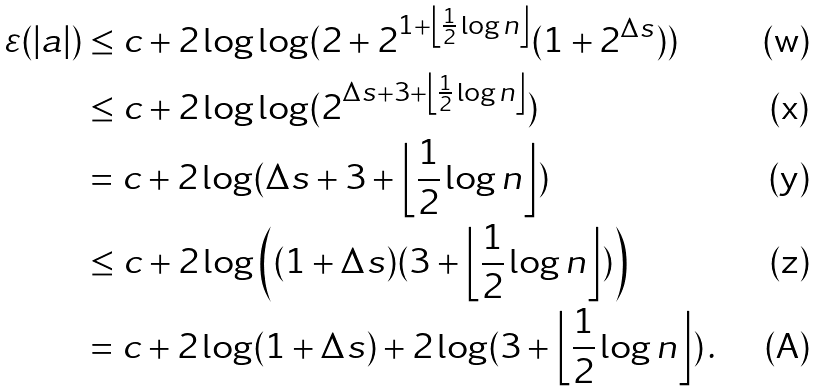Convert formula to latex. <formula><loc_0><loc_0><loc_500><loc_500>\varepsilon ( | a | ) & \leq c + 2 \log \log ( 2 + 2 ^ { 1 + \left \lfloor \frac { 1 } { 2 } \log n \right \rfloor } ( 1 + 2 ^ { \Delta s } ) ) \\ & \leq c + 2 \log \log ( 2 ^ { \Delta s + 3 + \left \lfloor \frac { 1 } { 2 } \log n \right \rfloor } ) \\ & = c + 2 \log ( \Delta s + 3 + \left \lfloor \frac { 1 } { 2 } \log n \right \rfloor ) \\ & \leq c + 2 \log \left ( ( 1 + \Delta s ) ( 3 + \left \lfloor \frac { 1 } { 2 } \log n \right \rfloor ) \right ) \\ & = c + 2 \log ( 1 + \Delta s ) + 2 \log ( 3 + \left \lfloor \frac { 1 } { 2 } \log n \right \rfloor ) \, .</formula> 